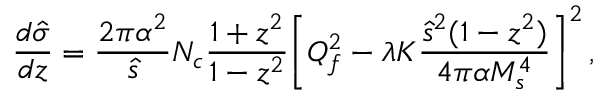Convert formula to latex. <formula><loc_0><loc_0><loc_500><loc_500>{ \frac { d \hat { \sigma } } { d z } } = { \frac { 2 \pi \alpha ^ { 2 } } { \hat { s } } } N _ { c } { \frac { 1 + z ^ { 2 } } { 1 - z ^ { 2 } } } \left [ Q _ { f } ^ { 2 } - \lambda K { \frac { \hat { s } ^ { 2 } ( 1 - z ^ { 2 } ) } { 4 \pi \alpha M _ { s } ^ { 4 } } } \right ] ^ { 2 } \, ,</formula> 